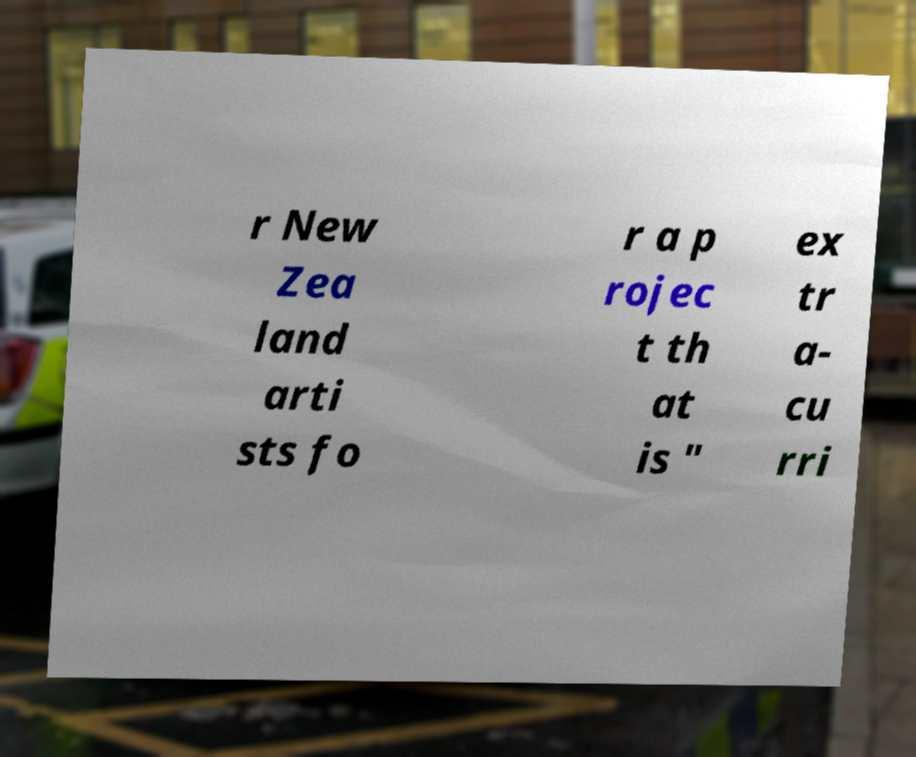What messages or text are displayed in this image? I need them in a readable, typed format. r New Zea land arti sts fo r a p rojec t th at is " ex tr a- cu rri 